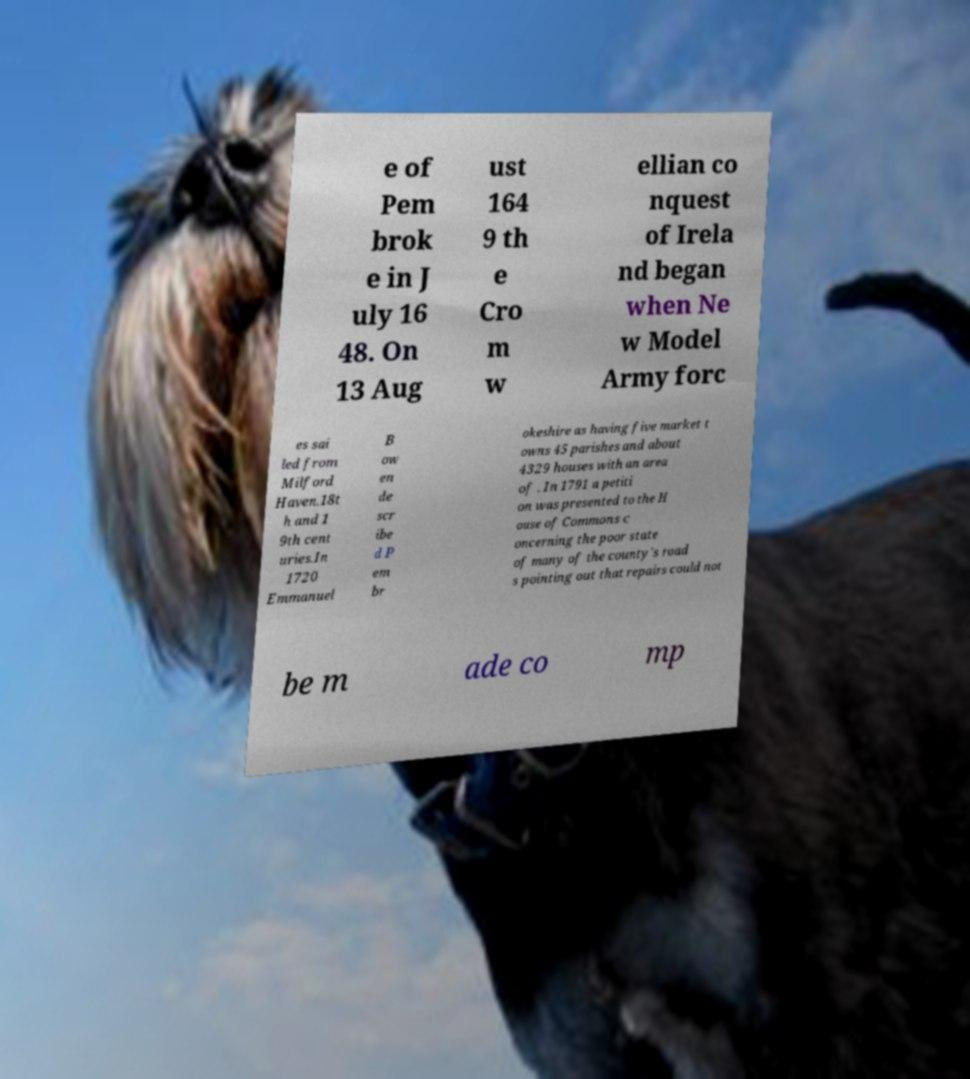Can you read and provide the text displayed in the image?This photo seems to have some interesting text. Can you extract and type it out for me? e of Pem brok e in J uly 16 48. On 13 Aug ust 164 9 th e Cro m w ellian co nquest of Irela nd began when Ne w Model Army forc es sai led from Milford Haven.18t h and 1 9th cent uries.In 1720 Emmanuel B ow en de scr ibe d P em br okeshire as having five market t owns 45 parishes and about 4329 houses with an area of . In 1791 a petiti on was presented to the H ouse of Commons c oncerning the poor state of many of the county's road s pointing out that repairs could not be m ade co mp 